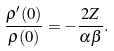<formula> <loc_0><loc_0><loc_500><loc_500>\frac { \rho ^ { \prime } ( 0 ) } { \rho ( 0 ) } = - \frac { 2 Z } { \alpha \beta } .</formula> 